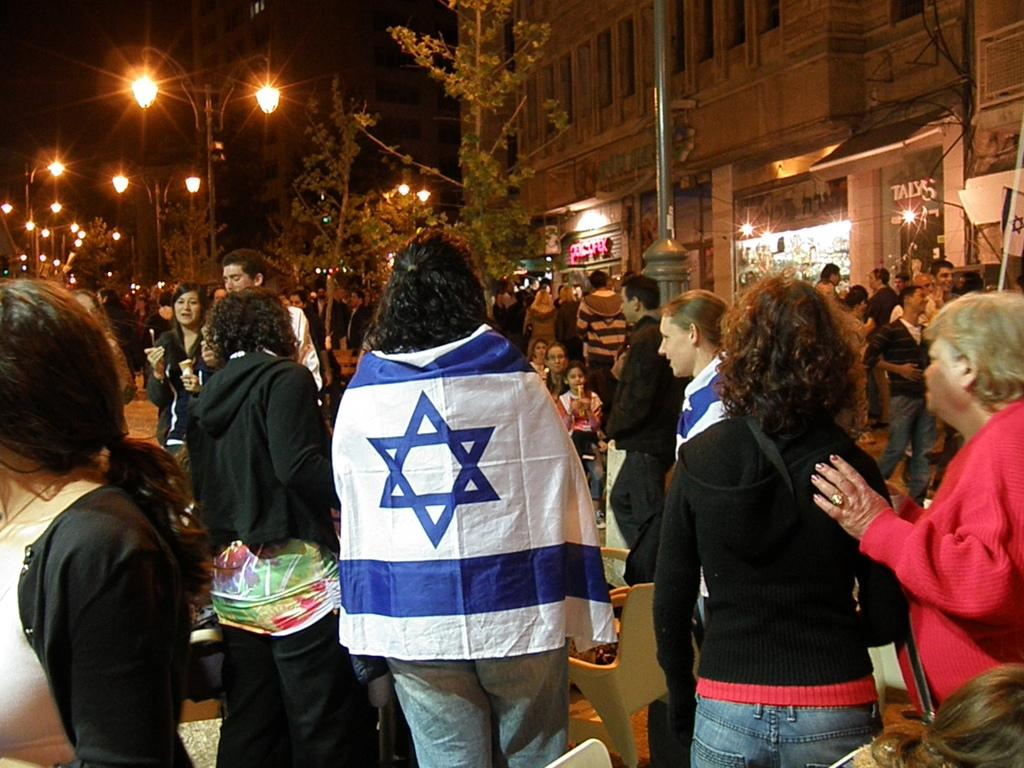What is happening in the image? There are people standing in the image, which suggests they might be in a public area or event. What can be seen in the background of the image? There are buildings, poles, lights, trees, and the sky visible in the background of the image. What type of establishments are present in the image? There are stores in the image. Can you tell me how many ladybugs are crawling on the stores in the image? There are no ladybugs present in the image; it features people standing and stores in the background. What type of meal is being served in the image? There is no meal visible in the image; it focuses on people standing and the surrounding environment. 